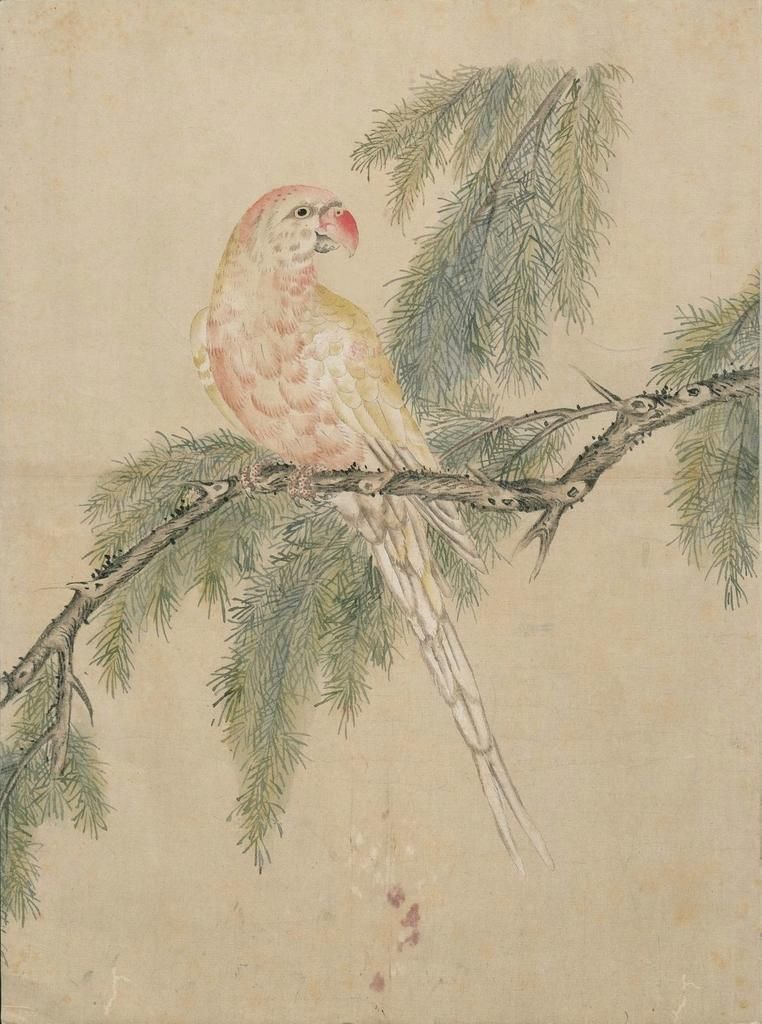What is depicted in the painting in the image? There is a painting of a bird in the image. Where is the bird located in the painting? The bird is on a branch in the painting. What other elements can be seen in the painting? Leaves and stems are visible in the image. What color is the background of the painting? The background of the image is cream-colored. What type of thread is used to create the bird's wings in the image? There is no thread present in the image, as it is a painting of a bird and not a physical object. 